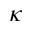<formula> <loc_0><loc_0><loc_500><loc_500>\kappa</formula> 